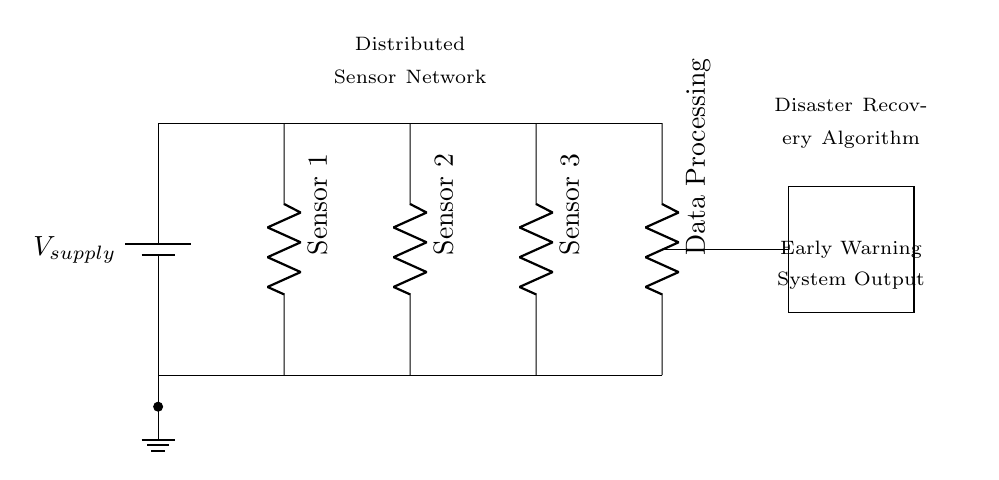What type of circuit is represented? This circuit is a parallel circuit because the components (sensors and data processing unit) are connected across the same voltage source. Each branch operates independently while sharing the same power supply.
Answer: Parallel How many sensors are included in the circuit? The circuit diagram shows three sensors labeled as Sensor 1, Sensor 2, and Sensor 3, which are connected in parallel.
Answer: Three What is the role of the data processing unit? The data processing unit serves to collect and analyze the data from the sensors, and it's located at the end of the circuit, indicating it processes information after sensor readings are taken.
Answer: Data processing What type of output does the early warning system provide? The early warning system provides warning signals based on the processed data, and this is indicated by the labeled box at the end of the circuit.
Answer: Warning What is the main advantage of using a parallel circuit in sensor networks? The main advantage of a parallel circuit is redundancy; if one sensor fails, the others continue to operate, ensuring uninterrupted sensor data collection for the early warning system.
Answer: Redundancy How are the sensors connected to the voltage supply? The sensors are connected directly to the same voltage supply in parallel, ensuring that each sensor receives the same voltage for proper operation.
Answer: Parallel connection 